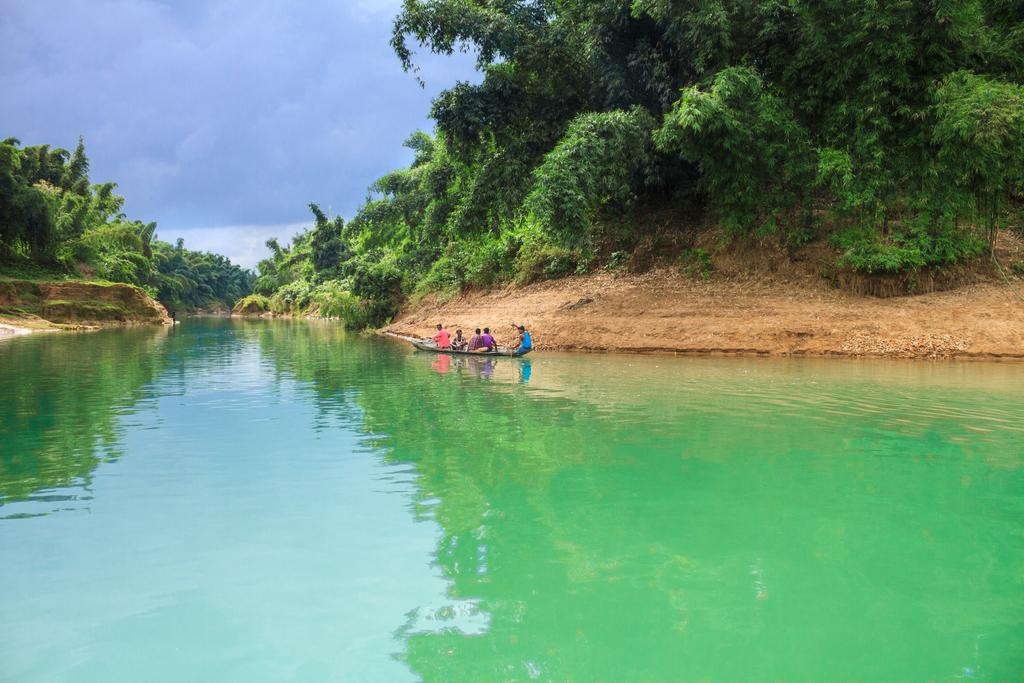What is the main subject of the image? The main subject of the image is a boat. Where is the boat located? The boat is on water. Are there any people on the boat? Yes, there are people on the boat. What can be seen in the background of the image? There are trees and the sky visible in the background of the image. What type of garden can be seen on the boat in the image? There is no garden present on the boat in the image. What is the secretary doing on the boat in the image? There is no secretary present on the boat in the image. 